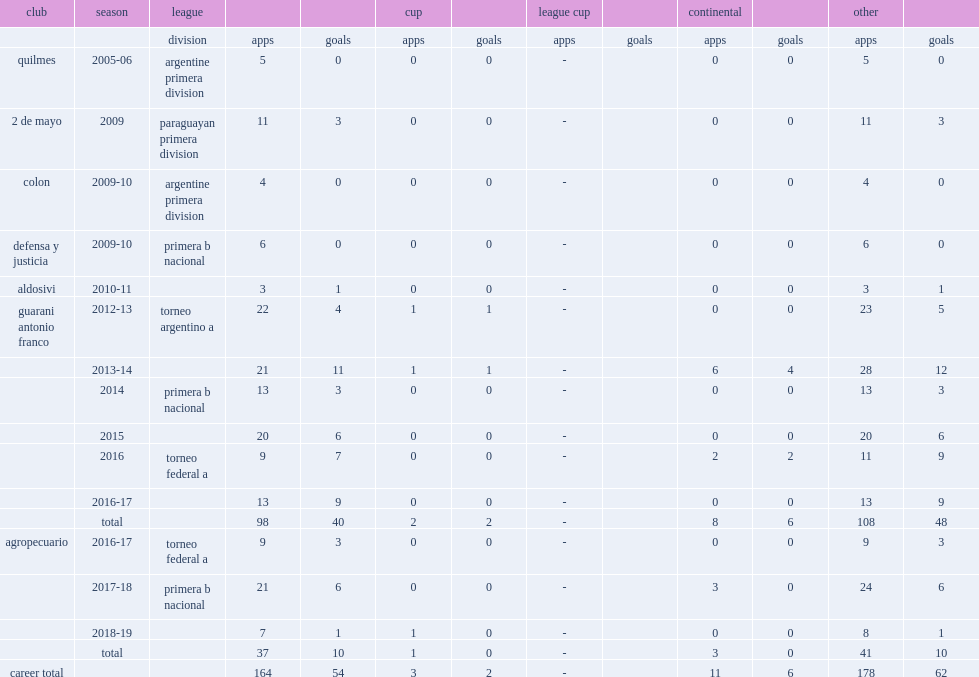Which club did barinaga play for in 2016-17? Agropecuario. 